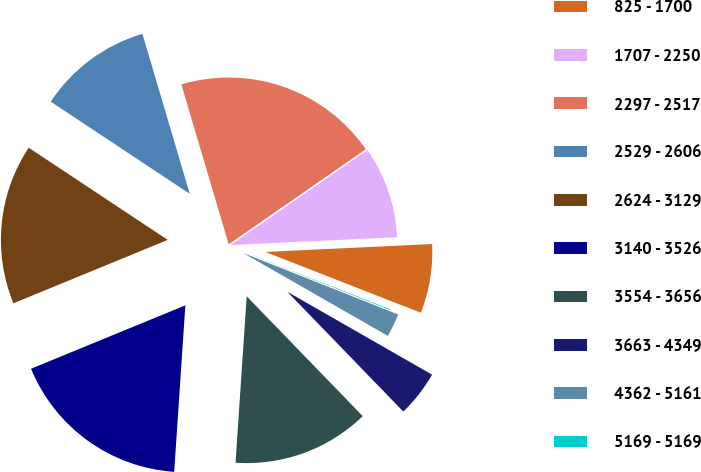Convert chart. <chart><loc_0><loc_0><loc_500><loc_500><pie_chart><fcel>825 - 1700<fcel>1707 - 2250<fcel>2297 - 2517<fcel>2529 - 2606<fcel>2624 - 3129<fcel>3140 - 3526<fcel>3554 - 3656<fcel>3663 - 4349<fcel>4362 - 5161<fcel>5169 - 5169<nl><fcel>6.69%<fcel>8.9%<fcel>19.93%<fcel>11.1%<fcel>15.52%<fcel>17.73%<fcel>13.31%<fcel>4.48%<fcel>2.27%<fcel>0.07%<nl></chart> 